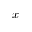Convert formula to latex. <formula><loc_0><loc_0><loc_500><loc_500>x</formula> 